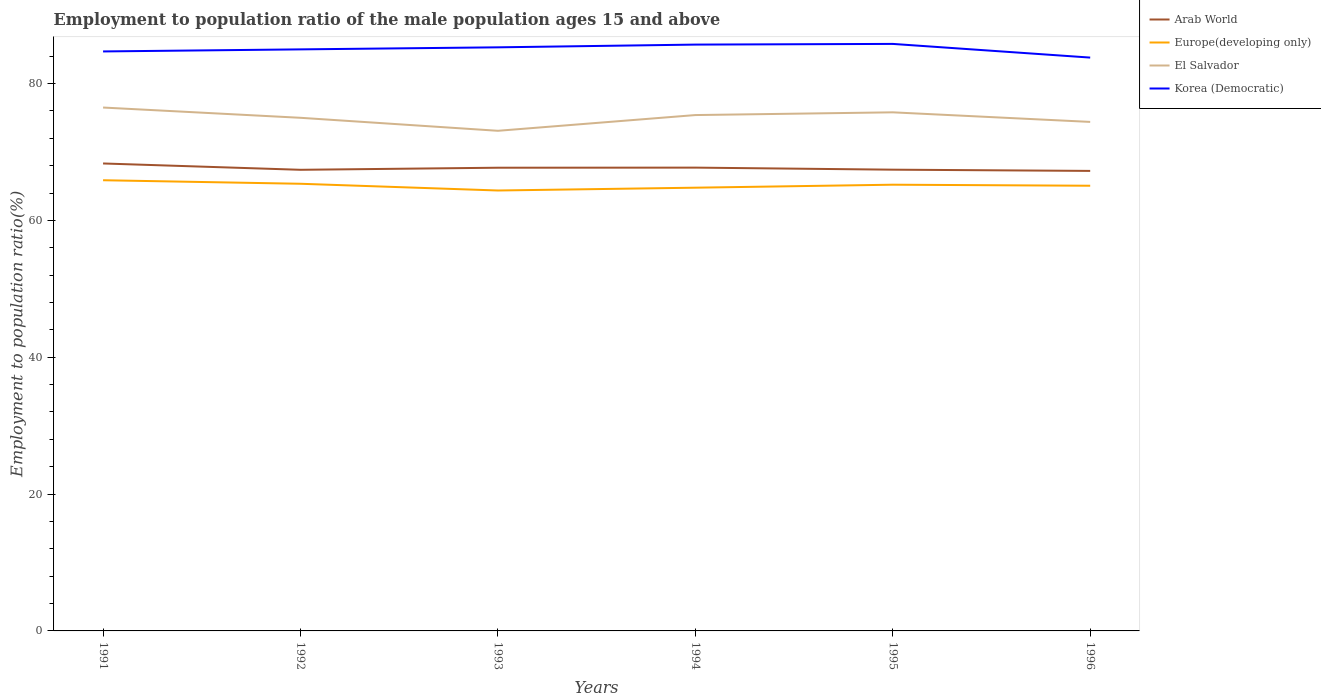Is the number of lines equal to the number of legend labels?
Make the answer very short. Yes. Across all years, what is the maximum employment to population ratio in Korea (Democratic)?
Your response must be concise. 83.8. In which year was the employment to population ratio in Europe(developing only) maximum?
Provide a succinct answer. 1993. What is the total employment to population ratio in El Salvador in the graph?
Offer a terse response. -2.7. What is the difference between the highest and the second highest employment to population ratio in El Salvador?
Make the answer very short. 3.4. Is the employment to population ratio in Korea (Democratic) strictly greater than the employment to population ratio in Arab World over the years?
Your answer should be very brief. No. How many lines are there?
Offer a terse response. 4. What is the difference between two consecutive major ticks on the Y-axis?
Provide a succinct answer. 20. Does the graph contain any zero values?
Ensure brevity in your answer.  No. Does the graph contain grids?
Keep it short and to the point. No. Where does the legend appear in the graph?
Provide a short and direct response. Top right. How many legend labels are there?
Provide a short and direct response. 4. How are the legend labels stacked?
Your answer should be very brief. Vertical. What is the title of the graph?
Your answer should be compact. Employment to population ratio of the male population ages 15 and above. Does "Argentina" appear as one of the legend labels in the graph?
Provide a short and direct response. No. What is the Employment to population ratio(%) in Arab World in 1991?
Make the answer very short. 68.32. What is the Employment to population ratio(%) of Europe(developing only) in 1991?
Provide a short and direct response. 65.87. What is the Employment to population ratio(%) of El Salvador in 1991?
Keep it short and to the point. 76.5. What is the Employment to population ratio(%) in Korea (Democratic) in 1991?
Ensure brevity in your answer.  84.7. What is the Employment to population ratio(%) in Arab World in 1992?
Ensure brevity in your answer.  67.4. What is the Employment to population ratio(%) of Europe(developing only) in 1992?
Offer a very short reply. 65.36. What is the Employment to population ratio(%) in El Salvador in 1992?
Your answer should be very brief. 75. What is the Employment to population ratio(%) of Korea (Democratic) in 1992?
Offer a terse response. 85. What is the Employment to population ratio(%) in Arab World in 1993?
Provide a succinct answer. 67.7. What is the Employment to population ratio(%) in Europe(developing only) in 1993?
Ensure brevity in your answer.  64.37. What is the Employment to population ratio(%) in El Salvador in 1993?
Your response must be concise. 73.1. What is the Employment to population ratio(%) in Korea (Democratic) in 1993?
Offer a very short reply. 85.3. What is the Employment to population ratio(%) in Arab World in 1994?
Offer a terse response. 67.72. What is the Employment to population ratio(%) of Europe(developing only) in 1994?
Make the answer very short. 64.78. What is the Employment to population ratio(%) of El Salvador in 1994?
Offer a terse response. 75.4. What is the Employment to population ratio(%) of Korea (Democratic) in 1994?
Your response must be concise. 85.7. What is the Employment to population ratio(%) in Arab World in 1995?
Offer a terse response. 67.42. What is the Employment to population ratio(%) in Europe(developing only) in 1995?
Offer a terse response. 65.22. What is the Employment to population ratio(%) in El Salvador in 1995?
Offer a terse response. 75.8. What is the Employment to population ratio(%) in Korea (Democratic) in 1995?
Your answer should be compact. 85.8. What is the Employment to population ratio(%) of Arab World in 1996?
Provide a succinct answer. 67.24. What is the Employment to population ratio(%) of Europe(developing only) in 1996?
Offer a very short reply. 65.07. What is the Employment to population ratio(%) of El Salvador in 1996?
Keep it short and to the point. 74.4. What is the Employment to population ratio(%) of Korea (Democratic) in 1996?
Ensure brevity in your answer.  83.8. Across all years, what is the maximum Employment to population ratio(%) of Arab World?
Offer a terse response. 68.32. Across all years, what is the maximum Employment to population ratio(%) of Europe(developing only)?
Your answer should be very brief. 65.87. Across all years, what is the maximum Employment to population ratio(%) of El Salvador?
Your answer should be compact. 76.5. Across all years, what is the maximum Employment to population ratio(%) in Korea (Democratic)?
Your answer should be very brief. 85.8. Across all years, what is the minimum Employment to population ratio(%) of Arab World?
Offer a very short reply. 67.24. Across all years, what is the minimum Employment to population ratio(%) in Europe(developing only)?
Ensure brevity in your answer.  64.37. Across all years, what is the minimum Employment to population ratio(%) in El Salvador?
Offer a very short reply. 73.1. Across all years, what is the minimum Employment to population ratio(%) of Korea (Democratic)?
Your answer should be compact. 83.8. What is the total Employment to population ratio(%) of Arab World in the graph?
Provide a succinct answer. 405.8. What is the total Employment to population ratio(%) in Europe(developing only) in the graph?
Ensure brevity in your answer.  390.68. What is the total Employment to population ratio(%) of El Salvador in the graph?
Keep it short and to the point. 450.2. What is the total Employment to population ratio(%) in Korea (Democratic) in the graph?
Offer a very short reply. 510.3. What is the difference between the Employment to population ratio(%) in Arab World in 1991 and that in 1992?
Offer a terse response. 0.93. What is the difference between the Employment to population ratio(%) in Europe(developing only) in 1991 and that in 1992?
Make the answer very short. 0.52. What is the difference between the Employment to population ratio(%) in El Salvador in 1991 and that in 1992?
Offer a very short reply. 1.5. What is the difference between the Employment to population ratio(%) of Korea (Democratic) in 1991 and that in 1992?
Your answer should be very brief. -0.3. What is the difference between the Employment to population ratio(%) of Arab World in 1991 and that in 1993?
Offer a terse response. 0.62. What is the difference between the Employment to population ratio(%) of Europe(developing only) in 1991 and that in 1993?
Your answer should be very brief. 1.5. What is the difference between the Employment to population ratio(%) in El Salvador in 1991 and that in 1993?
Your answer should be very brief. 3.4. What is the difference between the Employment to population ratio(%) in Korea (Democratic) in 1991 and that in 1993?
Ensure brevity in your answer.  -0.6. What is the difference between the Employment to population ratio(%) in Arab World in 1991 and that in 1994?
Your answer should be very brief. 0.61. What is the difference between the Employment to population ratio(%) in Europe(developing only) in 1991 and that in 1994?
Give a very brief answer. 1.09. What is the difference between the Employment to population ratio(%) in Korea (Democratic) in 1991 and that in 1994?
Your response must be concise. -1. What is the difference between the Employment to population ratio(%) in Arab World in 1991 and that in 1995?
Give a very brief answer. 0.91. What is the difference between the Employment to population ratio(%) of Europe(developing only) in 1991 and that in 1995?
Your response must be concise. 0.65. What is the difference between the Employment to population ratio(%) of Arab World in 1991 and that in 1996?
Offer a very short reply. 1.09. What is the difference between the Employment to population ratio(%) in Europe(developing only) in 1991 and that in 1996?
Provide a short and direct response. 0.8. What is the difference between the Employment to population ratio(%) of Arab World in 1992 and that in 1993?
Keep it short and to the point. -0.31. What is the difference between the Employment to population ratio(%) of Europe(developing only) in 1992 and that in 1993?
Your answer should be very brief. 0.99. What is the difference between the Employment to population ratio(%) of El Salvador in 1992 and that in 1993?
Offer a very short reply. 1.9. What is the difference between the Employment to population ratio(%) of Korea (Democratic) in 1992 and that in 1993?
Your response must be concise. -0.3. What is the difference between the Employment to population ratio(%) of Arab World in 1992 and that in 1994?
Ensure brevity in your answer.  -0.32. What is the difference between the Employment to population ratio(%) of Europe(developing only) in 1992 and that in 1994?
Offer a terse response. 0.57. What is the difference between the Employment to population ratio(%) of El Salvador in 1992 and that in 1994?
Provide a short and direct response. -0.4. What is the difference between the Employment to population ratio(%) in Korea (Democratic) in 1992 and that in 1994?
Give a very brief answer. -0.7. What is the difference between the Employment to population ratio(%) in Arab World in 1992 and that in 1995?
Your answer should be compact. -0.02. What is the difference between the Employment to population ratio(%) of Europe(developing only) in 1992 and that in 1995?
Offer a terse response. 0.14. What is the difference between the Employment to population ratio(%) of El Salvador in 1992 and that in 1995?
Provide a short and direct response. -0.8. What is the difference between the Employment to population ratio(%) in Korea (Democratic) in 1992 and that in 1995?
Your response must be concise. -0.8. What is the difference between the Employment to population ratio(%) of Arab World in 1992 and that in 1996?
Offer a terse response. 0.16. What is the difference between the Employment to population ratio(%) of Europe(developing only) in 1992 and that in 1996?
Provide a short and direct response. 0.29. What is the difference between the Employment to population ratio(%) of Arab World in 1993 and that in 1994?
Your answer should be compact. -0.01. What is the difference between the Employment to population ratio(%) in Europe(developing only) in 1993 and that in 1994?
Your response must be concise. -0.41. What is the difference between the Employment to population ratio(%) of El Salvador in 1993 and that in 1994?
Provide a succinct answer. -2.3. What is the difference between the Employment to population ratio(%) of Arab World in 1993 and that in 1995?
Keep it short and to the point. 0.29. What is the difference between the Employment to population ratio(%) in Europe(developing only) in 1993 and that in 1995?
Keep it short and to the point. -0.85. What is the difference between the Employment to population ratio(%) of Korea (Democratic) in 1993 and that in 1995?
Make the answer very short. -0.5. What is the difference between the Employment to population ratio(%) in Arab World in 1993 and that in 1996?
Your answer should be very brief. 0.47. What is the difference between the Employment to population ratio(%) in Europe(developing only) in 1993 and that in 1996?
Make the answer very short. -0.7. What is the difference between the Employment to population ratio(%) of El Salvador in 1993 and that in 1996?
Ensure brevity in your answer.  -1.3. What is the difference between the Employment to population ratio(%) of Korea (Democratic) in 1993 and that in 1996?
Make the answer very short. 1.5. What is the difference between the Employment to population ratio(%) of Arab World in 1994 and that in 1995?
Your answer should be compact. 0.3. What is the difference between the Employment to population ratio(%) of Europe(developing only) in 1994 and that in 1995?
Offer a very short reply. -0.44. What is the difference between the Employment to population ratio(%) of Korea (Democratic) in 1994 and that in 1995?
Provide a short and direct response. -0.1. What is the difference between the Employment to population ratio(%) of Arab World in 1994 and that in 1996?
Offer a terse response. 0.48. What is the difference between the Employment to population ratio(%) of Europe(developing only) in 1994 and that in 1996?
Provide a short and direct response. -0.29. What is the difference between the Employment to population ratio(%) of El Salvador in 1994 and that in 1996?
Offer a terse response. 1. What is the difference between the Employment to population ratio(%) in Korea (Democratic) in 1994 and that in 1996?
Ensure brevity in your answer.  1.9. What is the difference between the Employment to population ratio(%) of Arab World in 1995 and that in 1996?
Offer a terse response. 0.18. What is the difference between the Employment to population ratio(%) in Europe(developing only) in 1995 and that in 1996?
Provide a short and direct response. 0.15. What is the difference between the Employment to population ratio(%) in El Salvador in 1995 and that in 1996?
Give a very brief answer. 1.4. What is the difference between the Employment to population ratio(%) of Korea (Democratic) in 1995 and that in 1996?
Your response must be concise. 2. What is the difference between the Employment to population ratio(%) in Arab World in 1991 and the Employment to population ratio(%) in Europe(developing only) in 1992?
Give a very brief answer. 2.97. What is the difference between the Employment to population ratio(%) of Arab World in 1991 and the Employment to population ratio(%) of El Salvador in 1992?
Provide a succinct answer. -6.67. What is the difference between the Employment to population ratio(%) in Arab World in 1991 and the Employment to population ratio(%) in Korea (Democratic) in 1992?
Your answer should be very brief. -16.68. What is the difference between the Employment to population ratio(%) of Europe(developing only) in 1991 and the Employment to population ratio(%) of El Salvador in 1992?
Keep it short and to the point. -9.13. What is the difference between the Employment to population ratio(%) in Europe(developing only) in 1991 and the Employment to population ratio(%) in Korea (Democratic) in 1992?
Your response must be concise. -19.13. What is the difference between the Employment to population ratio(%) of El Salvador in 1991 and the Employment to population ratio(%) of Korea (Democratic) in 1992?
Your response must be concise. -8.5. What is the difference between the Employment to population ratio(%) in Arab World in 1991 and the Employment to population ratio(%) in Europe(developing only) in 1993?
Your response must be concise. 3.95. What is the difference between the Employment to population ratio(%) of Arab World in 1991 and the Employment to population ratio(%) of El Salvador in 1993?
Your answer should be compact. -4.78. What is the difference between the Employment to population ratio(%) of Arab World in 1991 and the Employment to population ratio(%) of Korea (Democratic) in 1993?
Provide a short and direct response. -16.98. What is the difference between the Employment to population ratio(%) in Europe(developing only) in 1991 and the Employment to population ratio(%) in El Salvador in 1993?
Offer a very short reply. -7.23. What is the difference between the Employment to population ratio(%) in Europe(developing only) in 1991 and the Employment to population ratio(%) in Korea (Democratic) in 1993?
Make the answer very short. -19.43. What is the difference between the Employment to population ratio(%) of Arab World in 1991 and the Employment to population ratio(%) of Europe(developing only) in 1994?
Keep it short and to the point. 3.54. What is the difference between the Employment to population ratio(%) of Arab World in 1991 and the Employment to population ratio(%) of El Salvador in 1994?
Offer a terse response. -7.08. What is the difference between the Employment to population ratio(%) of Arab World in 1991 and the Employment to population ratio(%) of Korea (Democratic) in 1994?
Provide a short and direct response. -17.38. What is the difference between the Employment to population ratio(%) in Europe(developing only) in 1991 and the Employment to population ratio(%) in El Salvador in 1994?
Keep it short and to the point. -9.53. What is the difference between the Employment to population ratio(%) of Europe(developing only) in 1991 and the Employment to population ratio(%) of Korea (Democratic) in 1994?
Offer a very short reply. -19.83. What is the difference between the Employment to population ratio(%) of Arab World in 1991 and the Employment to population ratio(%) of Europe(developing only) in 1995?
Keep it short and to the point. 3.1. What is the difference between the Employment to population ratio(%) in Arab World in 1991 and the Employment to population ratio(%) in El Salvador in 1995?
Offer a very short reply. -7.47. What is the difference between the Employment to population ratio(%) in Arab World in 1991 and the Employment to population ratio(%) in Korea (Democratic) in 1995?
Offer a very short reply. -17.48. What is the difference between the Employment to population ratio(%) in Europe(developing only) in 1991 and the Employment to population ratio(%) in El Salvador in 1995?
Provide a succinct answer. -9.93. What is the difference between the Employment to population ratio(%) of Europe(developing only) in 1991 and the Employment to population ratio(%) of Korea (Democratic) in 1995?
Offer a very short reply. -19.93. What is the difference between the Employment to population ratio(%) of Arab World in 1991 and the Employment to population ratio(%) of Europe(developing only) in 1996?
Your answer should be very brief. 3.26. What is the difference between the Employment to population ratio(%) of Arab World in 1991 and the Employment to population ratio(%) of El Salvador in 1996?
Ensure brevity in your answer.  -6.08. What is the difference between the Employment to population ratio(%) in Arab World in 1991 and the Employment to population ratio(%) in Korea (Democratic) in 1996?
Provide a succinct answer. -15.47. What is the difference between the Employment to population ratio(%) of Europe(developing only) in 1991 and the Employment to population ratio(%) of El Salvador in 1996?
Offer a terse response. -8.53. What is the difference between the Employment to population ratio(%) in Europe(developing only) in 1991 and the Employment to population ratio(%) in Korea (Democratic) in 1996?
Keep it short and to the point. -17.93. What is the difference between the Employment to population ratio(%) in El Salvador in 1991 and the Employment to population ratio(%) in Korea (Democratic) in 1996?
Make the answer very short. -7.3. What is the difference between the Employment to population ratio(%) in Arab World in 1992 and the Employment to population ratio(%) in Europe(developing only) in 1993?
Provide a succinct answer. 3.03. What is the difference between the Employment to population ratio(%) in Arab World in 1992 and the Employment to population ratio(%) in El Salvador in 1993?
Give a very brief answer. -5.7. What is the difference between the Employment to population ratio(%) in Arab World in 1992 and the Employment to population ratio(%) in Korea (Democratic) in 1993?
Ensure brevity in your answer.  -17.9. What is the difference between the Employment to population ratio(%) of Europe(developing only) in 1992 and the Employment to population ratio(%) of El Salvador in 1993?
Keep it short and to the point. -7.74. What is the difference between the Employment to population ratio(%) in Europe(developing only) in 1992 and the Employment to population ratio(%) in Korea (Democratic) in 1993?
Make the answer very short. -19.94. What is the difference between the Employment to population ratio(%) of Arab World in 1992 and the Employment to population ratio(%) of Europe(developing only) in 1994?
Provide a short and direct response. 2.61. What is the difference between the Employment to population ratio(%) in Arab World in 1992 and the Employment to population ratio(%) in El Salvador in 1994?
Ensure brevity in your answer.  -8. What is the difference between the Employment to population ratio(%) in Arab World in 1992 and the Employment to population ratio(%) in Korea (Democratic) in 1994?
Your answer should be very brief. -18.3. What is the difference between the Employment to population ratio(%) in Europe(developing only) in 1992 and the Employment to population ratio(%) in El Salvador in 1994?
Give a very brief answer. -10.04. What is the difference between the Employment to population ratio(%) of Europe(developing only) in 1992 and the Employment to population ratio(%) of Korea (Democratic) in 1994?
Make the answer very short. -20.34. What is the difference between the Employment to population ratio(%) in Arab World in 1992 and the Employment to population ratio(%) in Europe(developing only) in 1995?
Make the answer very short. 2.18. What is the difference between the Employment to population ratio(%) of Arab World in 1992 and the Employment to population ratio(%) of El Salvador in 1995?
Give a very brief answer. -8.4. What is the difference between the Employment to population ratio(%) in Arab World in 1992 and the Employment to population ratio(%) in Korea (Democratic) in 1995?
Offer a terse response. -18.4. What is the difference between the Employment to population ratio(%) in Europe(developing only) in 1992 and the Employment to population ratio(%) in El Salvador in 1995?
Your answer should be very brief. -10.44. What is the difference between the Employment to population ratio(%) of Europe(developing only) in 1992 and the Employment to population ratio(%) of Korea (Democratic) in 1995?
Ensure brevity in your answer.  -20.44. What is the difference between the Employment to population ratio(%) of El Salvador in 1992 and the Employment to population ratio(%) of Korea (Democratic) in 1995?
Give a very brief answer. -10.8. What is the difference between the Employment to population ratio(%) of Arab World in 1992 and the Employment to population ratio(%) of Europe(developing only) in 1996?
Offer a terse response. 2.33. What is the difference between the Employment to population ratio(%) in Arab World in 1992 and the Employment to population ratio(%) in El Salvador in 1996?
Your response must be concise. -7. What is the difference between the Employment to population ratio(%) in Arab World in 1992 and the Employment to population ratio(%) in Korea (Democratic) in 1996?
Make the answer very short. -16.4. What is the difference between the Employment to population ratio(%) in Europe(developing only) in 1992 and the Employment to population ratio(%) in El Salvador in 1996?
Ensure brevity in your answer.  -9.04. What is the difference between the Employment to population ratio(%) in Europe(developing only) in 1992 and the Employment to population ratio(%) in Korea (Democratic) in 1996?
Your answer should be compact. -18.44. What is the difference between the Employment to population ratio(%) in El Salvador in 1992 and the Employment to population ratio(%) in Korea (Democratic) in 1996?
Provide a short and direct response. -8.8. What is the difference between the Employment to population ratio(%) of Arab World in 1993 and the Employment to population ratio(%) of Europe(developing only) in 1994?
Ensure brevity in your answer.  2.92. What is the difference between the Employment to population ratio(%) in Arab World in 1993 and the Employment to population ratio(%) in El Salvador in 1994?
Offer a very short reply. -7.7. What is the difference between the Employment to population ratio(%) in Arab World in 1993 and the Employment to population ratio(%) in Korea (Democratic) in 1994?
Ensure brevity in your answer.  -18. What is the difference between the Employment to population ratio(%) in Europe(developing only) in 1993 and the Employment to population ratio(%) in El Salvador in 1994?
Your answer should be compact. -11.03. What is the difference between the Employment to population ratio(%) in Europe(developing only) in 1993 and the Employment to population ratio(%) in Korea (Democratic) in 1994?
Offer a terse response. -21.33. What is the difference between the Employment to population ratio(%) of El Salvador in 1993 and the Employment to population ratio(%) of Korea (Democratic) in 1994?
Offer a terse response. -12.6. What is the difference between the Employment to population ratio(%) of Arab World in 1993 and the Employment to population ratio(%) of Europe(developing only) in 1995?
Give a very brief answer. 2.48. What is the difference between the Employment to population ratio(%) of Arab World in 1993 and the Employment to population ratio(%) of El Salvador in 1995?
Give a very brief answer. -8.1. What is the difference between the Employment to population ratio(%) in Arab World in 1993 and the Employment to population ratio(%) in Korea (Democratic) in 1995?
Your response must be concise. -18.1. What is the difference between the Employment to population ratio(%) in Europe(developing only) in 1993 and the Employment to population ratio(%) in El Salvador in 1995?
Keep it short and to the point. -11.43. What is the difference between the Employment to population ratio(%) in Europe(developing only) in 1993 and the Employment to population ratio(%) in Korea (Democratic) in 1995?
Keep it short and to the point. -21.43. What is the difference between the Employment to population ratio(%) of Arab World in 1993 and the Employment to population ratio(%) of Europe(developing only) in 1996?
Offer a very short reply. 2.64. What is the difference between the Employment to population ratio(%) in Arab World in 1993 and the Employment to population ratio(%) in El Salvador in 1996?
Make the answer very short. -6.7. What is the difference between the Employment to population ratio(%) in Arab World in 1993 and the Employment to population ratio(%) in Korea (Democratic) in 1996?
Your answer should be compact. -16.1. What is the difference between the Employment to population ratio(%) in Europe(developing only) in 1993 and the Employment to population ratio(%) in El Salvador in 1996?
Ensure brevity in your answer.  -10.03. What is the difference between the Employment to population ratio(%) of Europe(developing only) in 1993 and the Employment to population ratio(%) of Korea (Democratic) in 1996?
Your response must be concise. -19.43. What is the difference between the Employment to population ratio(%) in Arab World in 1994 and the Employment to population ratio(%) in Europe(developing only) in 1995?
Your answer should be very brief. 2.5. What is the difference between the Employment to population ratio(%) in Arab World in 1994 and the Employment to population ratio(%) in El Salvador in 1995?
Give a very brief answer. -8.08. What is the difference between the Employment to population ratio(%) of Arab World in 1994 and the Employment to population ratio(%) of Korea (Democratic) in 1995?
Offer a very short reply. -18.08. What is the difference between the Employment to population ratio(%) of Europe(developing only) in 1994 and the Employment to population ratio(%) of El Salvador in 1995?
Ensure brevity in your answer.  -11.02. What is the difference between the Employment to population ratio(%) in Europe(developing only) in 1994 and the Employment to population ratio(%) in Korea (Democratic) in 1995?
Your answer should be compact. -21.02. What is the difference between the Employment to population ratio(%) of El Salvador in 1994 and the Employment to population ratio(%) of Korea (Democratic) in 1995?
Keep it short and to the point. -10.4. What is the difference between the Employment to population ratio(%) in Arab World in 1994 and the Employment to population ratio(%) in Europe(developing only) in 1996?
Your response must be concise. 2.65. What is the difference between the Employment to population ratio(%) in Arab World in 1994 and the Employment to population ratio(%) in El Salvador in 1996?
Keep it short and to the point. -6.68. What is the difference between the Employment to population ratio(%) in Arab World in 1994 and the Employment to population ratio(%) in Korea (Democratic) in 1996?
Offer a terse response. -16.08. What is the difference between the Employment to population ratio(%) in Europe(developing only) in 1994 and the Employment to population ratio(%) in El Salvador in 1996?
Ensure brevity in your answer.  -9.62. What is the difference between the Employment to population ratio(%) in Europe(developing only) in 1994 and the Employment to population ratio(%) in Korea (Democratic) in 1996?
Provide a succinct answer. -19.02. What is the difference between the Employment to population ratio(%) of El Salvador in 1994 and the Employment to population ratio(%) of Korea (Democratic) in 1996?
Offer a very short reply. -8.4. What is the difference between the Employment to population ratio(%) of Arab World in 1995 and the Employment to population ratio(%) of Europe(developing only) in 1996?
Give a very brief answer. 2.35. What is the difference between the Employment to population ratio(%) of Arab World in 1995 and the Employment to population ratio(%) of El Salvador in 1996?
Offer a very short reply. -6.98. What is the difference between the Employment to population ratio(%) of Arab World in 1995 and the Employment to population ratio(%) of Korea (Democratic) in 1996?
Offer a very short reply. -16.38. What is the difference between the Employment to population ratio(%) in Europe(developing only) in 1995 and the Employment to population ratio(%) in El Salvador in 1996?
Offer a terse response. -9.18. What is the difference between the Employment to population ratio(%) of Europe(developing only) in 1995 and the Employment to population ratio(%) of Korea (Democratic) in 1996?
Give a very brief answer. -18.58. What is the average Employment to population ratio(%) in Arab World per year?
Ensure brevity in your answer.  67.63. What is the average Employment to population ratio(%) of Europe(developing only) per year?
Your response must be concise. 65.11. What is the average Employment to population ratio(%) in El Salvador per year?
Your answer should be compact. 75.03. What is the average Employment to population ratio(%) in Korea (Democratic) per year?
Keep it short and to the point. 85.05. In the year 1991, what is the difference between the Employment to population ratio(%) in Arab World and Employment to population ratio(%) in Europe(developing only)?
Your response must be concise. 2.45. In the year 1991, what is the difference between the Employment to population ratio(%) of Arab World and Employment to population ratio(%) of El Salvador?
Keep it short and to the point. -8.18. In the year 1991, what is the difference between the Employment to population ratio(%) in Arab World and Employment to population ratio(%) in Korea (Democratic)?
Ensure brevity in your answer.  -16.38. In the year 1991, what is the difference between the Employment to population ratio(%) in Europe(developing only) and Employment to population ratio(%) in El Salvador?
Offer a very short reply. -10.63. In the year 1991, what is the difference between the Employment to population ratio(%) in Europe(developing only) and Employment to population ratio(%) in Korea (Democratic)?
Provide a short and direct response. -18.83. In the year 1991, what is the difference between the Employment to population ratio(%) of El Salvador and Employment to population ratio(%) of Korea (Democratic)?
Your answer should be compact. -8.2. In the year 1992, what is the difference between the Employment to population ratio(%) in Arab World and Employment to population ratio(%) in Europe(developing only)?
Offer a very short reply. 2.04. In the year 1992, what is the difference between the Employment to population ratio(%) of Arab World and Employment to population ratio(%) of El Salvador?
Your answer should be compact. -7.6. In the year 1992, what is the difference between the Employment to population ratio(%) of Arab World and Employment to population ratio(%) of Korea (Democratic)?
Make the answer very short. -17.6. In the year 1992, what is the difference between the Employment to population ratio(%) of Europe(developing only) and Employment to population ratio(%) of El Salvador?
Your response must be concise. -9.64. In the year 1992, what is the difference between the Employment to population ratio(%) of Europe(developing only) and Employment to population ratio(%) of Korea (Democratic)?
Your answer should be very brief. -19.64. In the year 1992, what is the difference between the Employment to population ratio(%) of El Salvador and Employment to population ratio(%) of Korea (Democratic)?
Offer a terse response. -10. In the year 1993, what is the difference between the Employment to population ratio(%) in Arab World and Employment to population ratio(%) in Europe(developing only)?
Make the answer very short. 3.33. In the year 1993, what is the difference between the Employment to population ratio(%) in Arab World and Employment to population ratio(%) in El Salvador?
Give a very brief answer. -5.4. In the year 1993, what is the difference between the Employment to population ratio(%) in Arab World and Employment to population ratio(%) in Korea (Democratic)?
Give a very brief answer. -17.6. In the year 1993, what is the difference between the Employment to population ratio(%) of Europe(developing only) and Employment to population ratio(%) of El Salvador?
Offer a terse response. -8.73. In the year 1993, what is the difference between the Employment to population ratio(%) in Europe(developing only) and Employment to population ratio(%) in Korea (Democratic)?
Your response must be concise. -20.93. In the year 1994, what is the difference between the Employment to population ratio(%) of Arab World and Employment to population ratio(%) of Europe(developing only)?
Offer a terse response. 2.93. In the year 1994, what is the difference between the Employment to population ratio(%) in Arab World and Employment to population ratio(%) in El Salvador?
Your response must be concise. -7.68. In the year 1994, what is the difference between the Employment to population ratio(%) in Arab World and Employment to population ratio(%) in Korea (Democratic)?
Provide a succinct answer. -17.98. In the year 1994, what is the difference between the Employment to population ratio(%) in Europe(developing only) and Employment to population ratio(%) in El Salvador?
Your answer should be compact. -10.62. In the year 1994, what is the difference between the Employment to population ratio(%) of Europe(developing only) and Employment to population ratio(%) of Korea (Democratic)?
Make the answer very short. -20.92. In the year 1994, what is the difference between the Employment to population ratio(%) of El Salvador and Employment to population ratio(%) of Korea (Democratic)?
Ensure brevity in your answer.  -10.3. In the year 1995, what is the difference between the Employment to population ratio(%) of Arab World and Employment to population ratio(%) of Europe(developing only)?
Offer a very short reply. 2.2. In the year 1995, what is the difference between the Employment to population ratio(%) of Arab World and Employment to population ratio(%) of El Salvador?
Make the answer very short. -8.38. In the year 1995, what is the difference between the Employment to population ratio(%) in Arab World and Employment to population ratio(%) in Korea (Democratic)?
Ensure brevity in your answer.  -18.38. In the year 1995, what is the difference between the Employment to population ratio(%) in Europe(developing only) and Employment to population ratio(%) in El Salvador?
Your answer should be compact. -10.58. In the year 1995, what is the difference between the Employment to population ratio(%) in Europe(developing only) and Employment to population ratio(%) in Korea (Democratic)?
Offer a very short reply. -20.58. In the year 1995, what is the difference between the Employment to population ratio(%) in El Salvador and Employment to population ratio(%) in Korea (Democratic)?
Your answer should be very brief. -10. In the year 1996, what is the difference between the Employment to population ratio(%) in Arab World and Employment to population ratio(%) in Europe(developing only)?
Offer a terse response. 2.17. In the year 1996, what is the difference between the Employment to population ratio(%) of Arab World and Employment to population ratio(%) of El Salvador?
Make the answer very short. -7.16. In the year 1996, what is the difference between the Employment to population ratio(%) of Arab World and Employment to population ratio(%) of Korea (Democratic)?
Provide a short and direct response. -16.56. In the year 1996, what is the difference between the Employment to population ratio(%) of Europe(developing only) and Employment to population ratio(%) of El Salvador?
Offer a terse response. -9.33. In the year 1996, what is the difference between the Employment to population ratio(%) in Europe(developing only) and Employment to population ratio(%) in Korea (Democratic)?
Offer a terse response. -18.73. What is the ratio of the Employment to population ratio(%) of Arab World in 1991 to that in 1992?
Give a very brief answer. 1.01. What is the ratio of the Employment to population ratio(%) in Europe(developing only) in 1991 to that in 1992?
Provide a succinct answer. 1.01. What is the ratio of the Employment to population ratio(%) in El Salvador in 1991 to that in 1992?
Give a very brief answer. 1.02. What is the ratio of the Employment to population ratio(%) in Arab World in 1991 to that in 1993?
Keep it short and to the point. 1.01. What is the ratio of the Employment to population ratio(%) in Europe(developing only) in 1991 to that in 1993?
Make the answer very short. 1.02. What is the ratio of the Employment to population ratio(%) of El Salvador in 1991 to that in 1993?
Offer a very short reply. 1.05. What is the ratio of the Employment to population ratio(%) of Europe(developing only) in 1991 to that in 1994?
Your answer should be compact. 1.02. What is the ratio of the Employment to population ratio(%) in El Salvador in 1991 to that in 1994?
Make the answer very short. 1.01. What is the ratio of the Employment to population ratio(%) in Korea (Democratic) in 1991 to that in 1994?
Ensure brevity in your answer.  0.99. What is the ratio of the Employment to population ratio(%) of Arab World in 1991 to that in 1995?
Give a very brief answer. 1.01. What is the ratio of the Employment to population ratio(%) of Europe(developing only) in 1991 to that in 1995?
Give a very brief answer. 1.01. What is the ratio of the Employment to population ratio(%) in El Salvador in 1991 to that in 1995?
Offer a terse response. 1.01. What is the ratio of the Employment to population ratio(%) of Korea (Democratic) in 1991 to that in 1995?
Your answer should be very brief. 0.99. What is the ratio of the Employment to population ratio(%) of Arab World in 1991 to that in 1996?
Your response must be concise. 1.02. What is the ratio of the Employment to population ratio(%) in Europe(developing only) in 1991 to that in 1996?
Offer a terse response. 1.01. What is the ratio of the Employment to population ratio(%) of El Salvador in 1991 to that in 1996?
Your response must be concise. 1.03. What is the ratio of the Employment to population ratio(%) of Korea (Democratic) in 1991 to that in 1996?
Offer a very short reply. 1.01. What is the ratio of the Employment to population ratio(%) of Arab World in 1992 to that in 1993?
Offer a very short reply. 1. What is the ratio of the Employment to population ratio(%) in Europe(developing only) in 1992 to that in 1993?
Ensure brevity in your answer.  1.02. What is the ratio of the Employment to population ratio(%) of Korea (Democratic) in 1992 to that in 1993?
Make the answer very short. 1. What is the ratio of the Employment to population ratio(%) in Arab World in 1992 to that in 1994?
Your answer should be compact. 1. What is the ratio of the Employment to population ratio(%) in Europe(developing only) in 1992 to that in 1994?
Make the answer very short. 1.01. What is the ratio of the Employment to population ratio(%) of Korea (Democratic) in 1992 to that in 1994?
Your answer should be very brief. 0.99. What is the ratio of the Employment to population ratio(%) in Arab World in 1992 to that in 1995?
Offer a very short reply. 1. What is the ratio of the Employment to population ratio(%) of Europe(developing only) in 1992 to that in 1995?
Offer a very short reply. 1. What is the ratio of the Employment to population ratio(%) in Korea (Democratic) in 1992 to that in 1995?
Your response must be concise. 0.99. What is the ratio of the Employment to population ratio(%) in El Salvador in 1992 to that in 1996?
Your answer should be very brief. 1.01. What is the ratio of the Employment to population ratio(%) in Korea (Democratic) in 1992 to that in 1996?
Your answer should be compact. 1.01. What is the ratio of the Employment to population ratio(%) in El Salvador in 1993 to that in 1994?
Make the answer very short. 0.97. What is the ratio of the Employment to population ratio(%) in Europe(developing only) in 1993 to that in 1995?
Provide a short and direct response. 0.99. What is the ratio of the Employment to population ratio(%) in El Salvador in 1993 to that in 1995?
Provide a succinct answer. 0.96. What is the ratio of the Employment to population ratio(%) in Korea (Democratic) in 1993 to that in 1995?
Your answer should be compact. 0.99. What is the ratio of the Employment to population ratio(%) of Arab World in 1993 to that in 1996?
Offer a very short reply. 1.01. What is the ratio of the Employment to population ratio(%) of Europe(developing only) in 1993 to that in 1996?
Offer a very short reply. 0.99. What is the ratio of the Employment to population ratio(%) of El Salvador in 1993 to that in 1996?
Your answer should be very brief. 0.98. What is the ratio of the Employment to population ratio(%) of Korea (Democratic) in 1993 to that in 1996?
Keep it short and to the point. 1.02. What is the ratio of the Employment to population ratio(%) of Arab World in 1994 to that in 1995?
Ensure brevity in your answer.  1. What is the ratio of the Employment to population ratio(%) of Europe(developing only) in 1994 to that in 1995?
Keep it short and to the point. 0.99. What is the ratio of the Employment to population ratio(%) in Arab World in 1994 to that in 1996?
Provide a succinct answer. 1.01. What is the ratio of the Employment to population ratio(%) in El Salvador in 1994 to that in 1996?
Give a very brief answer. 1.01. What is the ratio of the Employment to population ratio(%) of Korea (Democratic) in 1994 to that in 1996?
Your response must be concise. 1.02. What is the ratio of the Employment to population ratio(%) in Europe(developing only) in 1995 to that in 1996?
Provide a succinct answer. 1. What is the ratio of the Employment to population ratio(%) in El Salvador in 1995 to that in 1996?
Offer a terse response. 1.02. What is the ratio of the Employment to population ratio(%) of Korea (Democratic) in 1995 to that in 1996?
Your answer should be compact. 1.02. What is the difference between the highest and the second highest Employment to population ratio(%) of Arab World?
Make the answer very short. 0.61. What is the difference between the highest and the second highest Employment to population ratio(%) of Europe(developing only)?
Offer a very short reply. 0.52. What is the difference between the highest and the second highest Employment to population ratio(%) of El Salvador?
Provide a short and direct response. 0.7. What is the difference between the highest and the lowest Employment to population ratio(%) in Arab World?
Ensure brevity in your answer.  1.09. What is the difference between the highest and the lowest Employment to population ratio(%) in Europe(developing only)?
Keep it short and to the point. 1.5. What is the difference between the highest and the lowest Employment to population ratio(%) of El Salvador?
Provide a succinct answer. 3.4. What is the difference between the highest and the lowest Employment to population ratio(%) of Korea (Democratic)?
Offer a terse response. 2. 